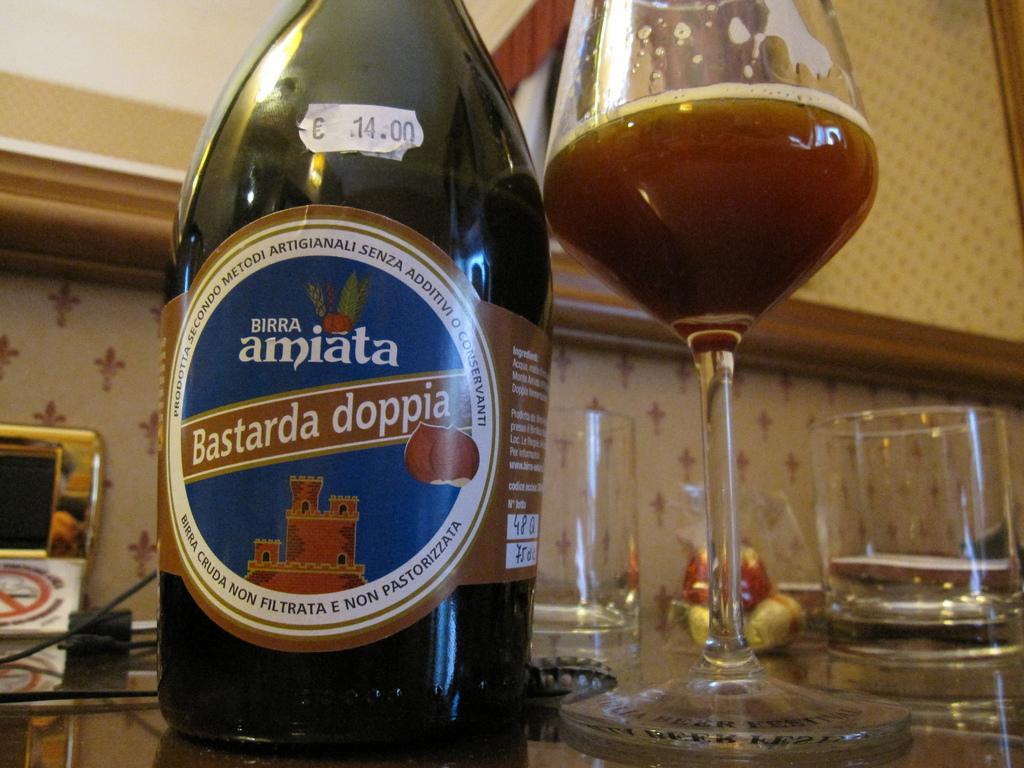Describe this image in one or two sentences. In this image we can see a group of objects on a surface. Behind the objects we can see a wall and a wooden frame is attached to the wall. 